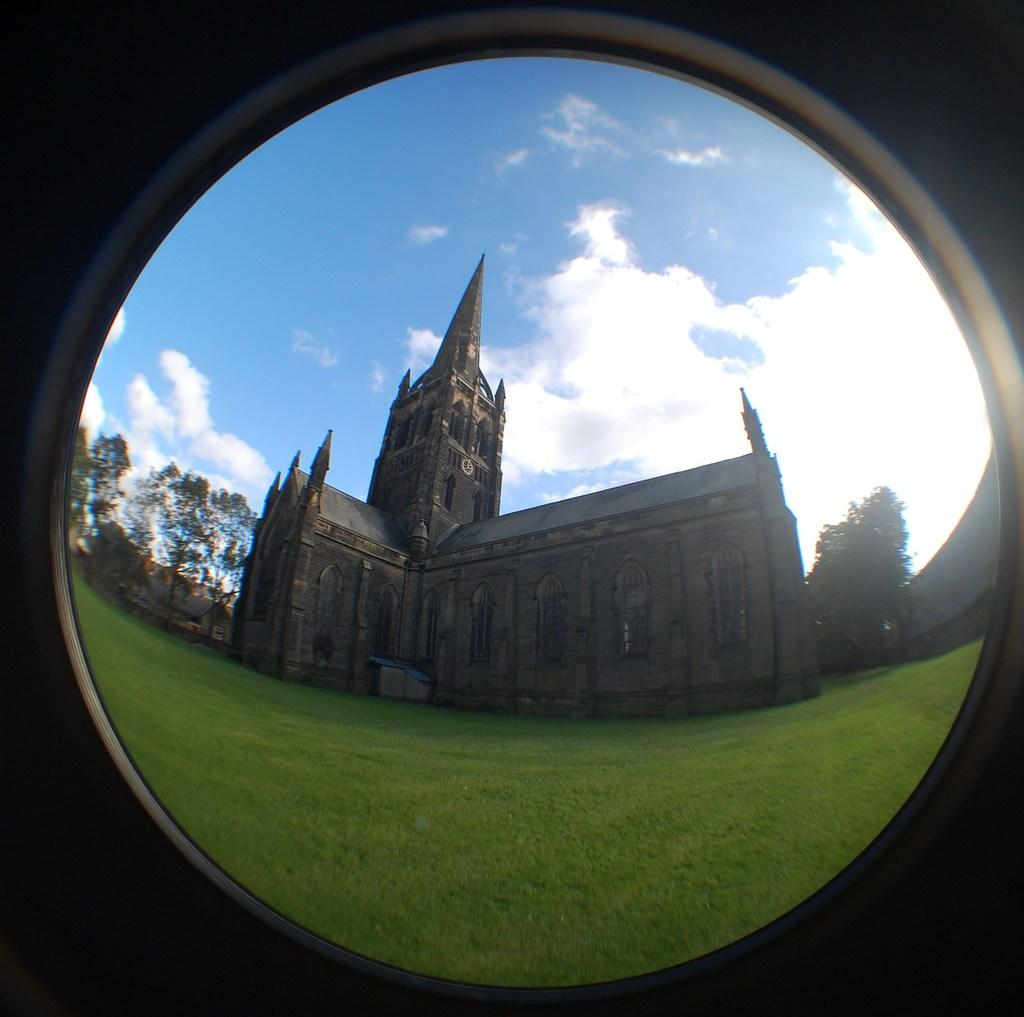What type of building can be seen in the image? There is a church present in the image. Can you describe the architecture of the church? The church appears to have an old architecture. What type of vegetation is visible in the image? There are trees and grass in the image. What is visible in the sky in the image? Clouds are visible in the sky. How many notebooks are placed on the church's roof in the image? There are no notebooks present in the image, and they are not placed on the church's roof. 